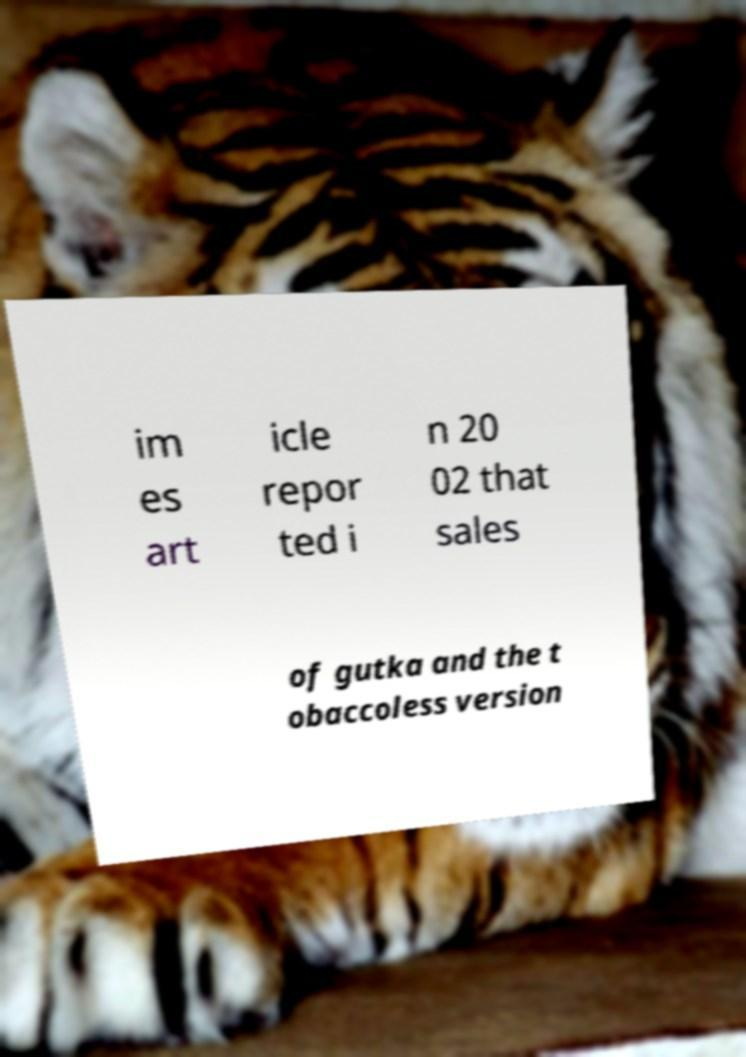I need the written content from this picture converted into text. Can you do that? im es art icle repor ted i n 20 02 that sales of gutka and the t obaccoless version 